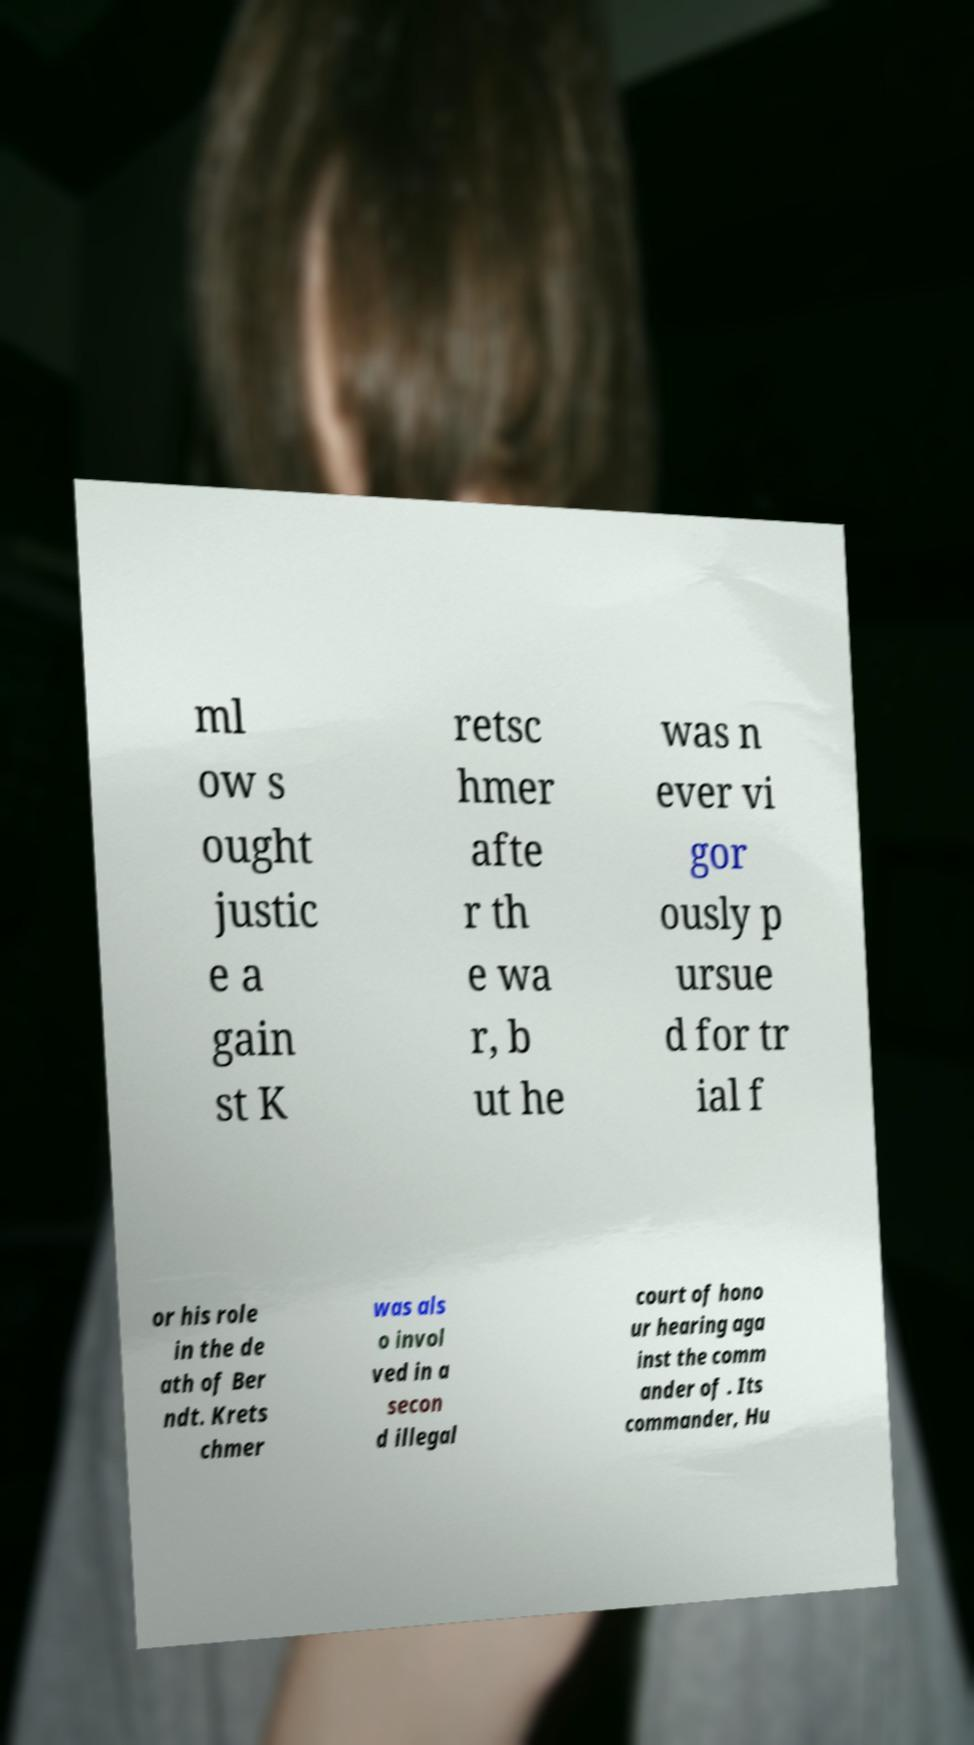I need the written content from this picture converted into text. Can you do that? ml ow s ought justic e a gain st K retsc hmer afte r th e wa r, b ut he was n ever vi gor ously p ursue d for tr ial f or his role in the de ath of Ber ndt. Krets chmer was als o invol ved in a secon d illegal court of hono ur hearing aga inst the comm ander of . Its commander, Hu 